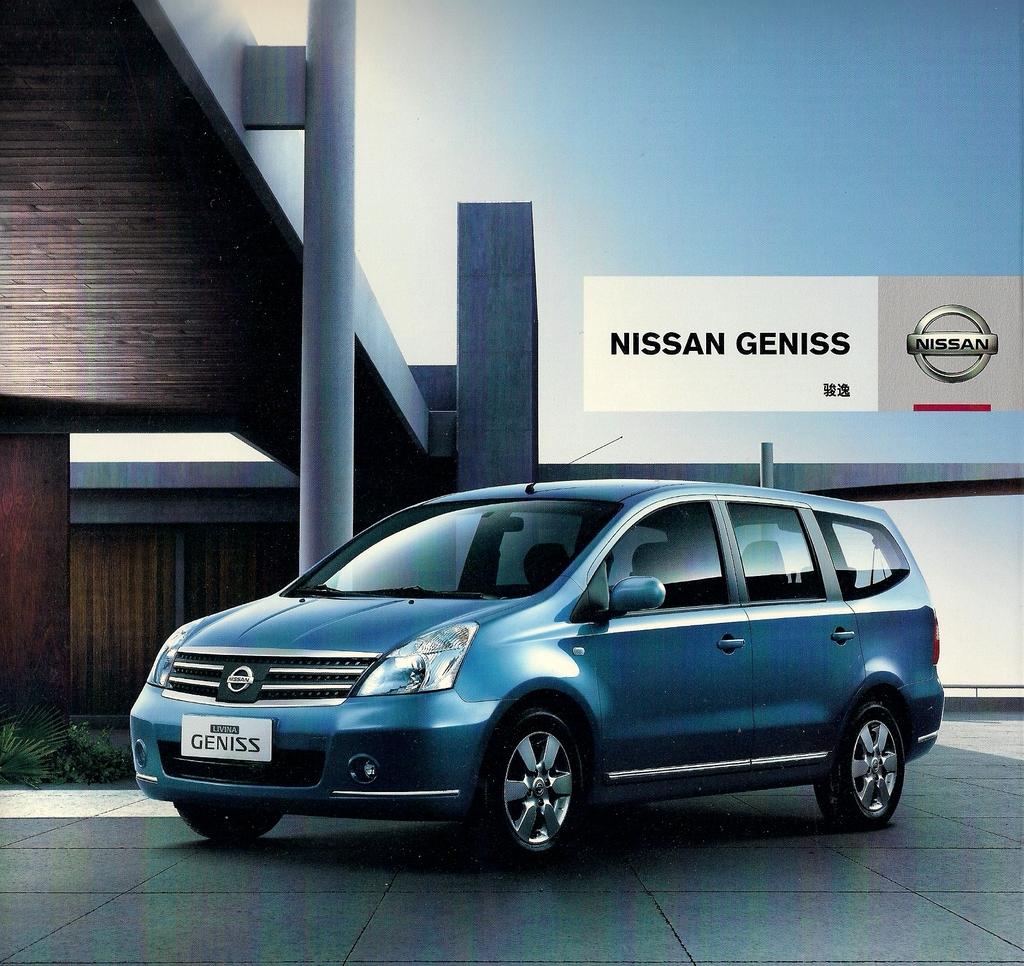What nissan model is this?
Make the answer very short. Geniss. 